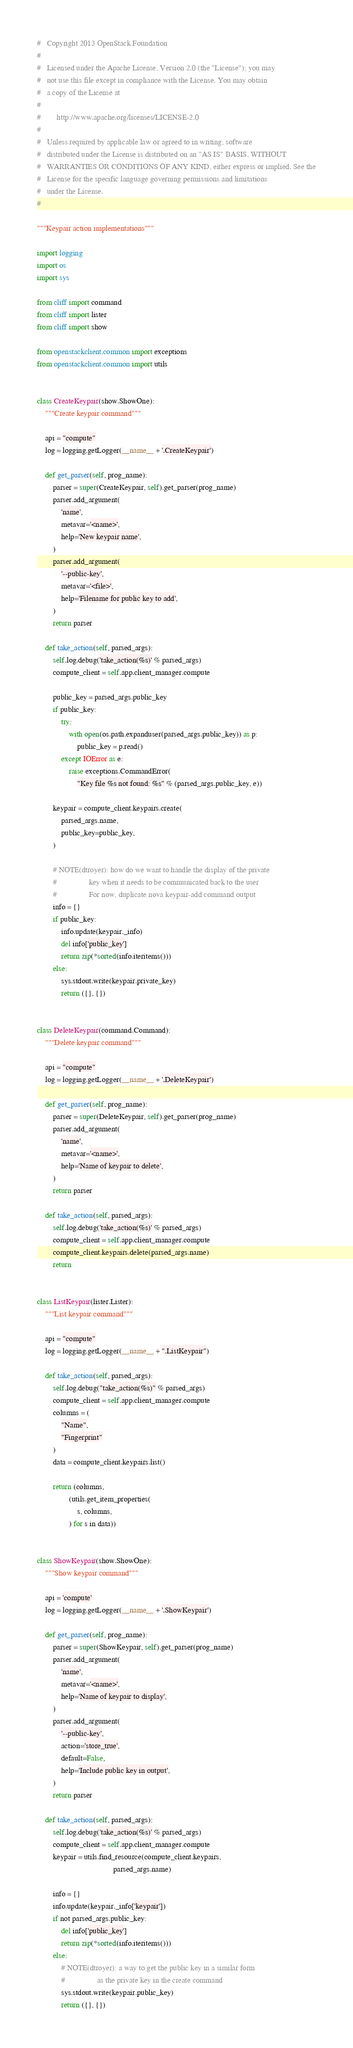Convert code to text. <code><loc_0><loc_0><loc_500><loc_500><_Python_>#   Copyright 2013 OpenStack Foundation
#
#   Licensed under the Apache License, Version 2.0 (the "License"); you may
#   not use this file except in compliance with the License. You may obtain
#   a copy of the License at
#
#        http://www.apache.org/licenses/LICENSE-2.0
#
#   Unless required by applicable law or agreed to in writing, software
#   distributed under the License is distributed on an "AS IS" BASIS, WITHOUT
#   WARRANTIES OR CONDITIONS OF ANY KIND, either express or implied. See the
#   License for the specific language governing permissions and limitations
#   under the License.
#

"""Keypair action implementations"""

import logging
import os
import sys

from cliff import command
from cliff import lister
from cliff import show

from openstackclient.common import exceptions
from openstackclient.common import utils


class CreateKeypair(show.ShowOne):
    """Create keypair command"""

    api = "compute"
    log = logging.getLogger(__name__ + '.CreateKeypair')

    def get_parser(self, prog_name):
        parser = super(CreateKeypair, self).get_parser(prog_name)
        parser.add_argument(
            'name',
            metavar='<name>',
            help='New keypair name',
        )
        parser.add_argument(
            '--public-key',
            metavar='<file>',
            help='Filename for public key to add',
        )
        return parser

    def take_action(self, parsed_args):
        self.log.debug('take_action(%s)' % parsed_args)
        compute_client = self.app.client_manager.compute

        public_key = parsed_args.public_key
        if public_key:
            try:
                with open(os.path.expanduser(parsed_args.public_key)) as p:
                    public_key = p.read()
            except IOError as e:
                raise exceptions.CommandError(
                    "Key file %s not found: %s" % (parsed_args.public_key, e))

        keypair = compute_client.keypairs.create(
            parsed_args.name,
            public_key=public_key,
        )

        # NOTE(dtroyer): how do we want to handle the display of the private
        #                key when it needs to be communicated back to the user
        #                For now, duplicate nova keypair-add command output
        info = {}
        if public_key:
            info.update(keypair._info)
            del info['public_key']
            return zip(*sorted(info.iteritems()))
        else:
            sys.stdout.write(keypair.private_key)
            return ({}, {})


class DeleteKeypair(command.Command):
    """Delete keypair command"""

    api = "compute"
    log = logging.getLogger(__name__ + '.DeleteKeypair')

    def get_parser(self, prog_name):
        parser = super(DeleteKeypair, self).get_parser(prog_name)
        parser.add_argument(
            'name',
            metavar='<name>',
            help='Name of keypair to delete',
        )
        return parser

    def take_action(self, parsed_args):
        self.log.debug('take_action(%s)' % parsed_args)
        compute_client = self.app.client_manager.compute
        compute_client.keypairs.delete(parsed_args.name)
        return


class ListKeypair(lister.Lister):
    """List keypair command"""

    api = "compute"
    log = logging.getLogger(__name__ + ".ListKeypair")

    def take_action(self, parsed_args):
        self.log.debug("take_action(%s)" % parsed_args)
        compute_client = self.app.client_manager.compute
        columns = (
            "Name",
            "Fingerprint"
        )
        data = compute_client.keypairs.list()

        return (columns,
                (utils.get_item_properties(
                    s, columns,
                ) for s in data))


class ShowKeypair(show.ShowOne):
    """Show keypair command"""

    api = 'compute'
    log = logging.getLogger(__name__ + '.ShowKeypair')

    def get_parser(self, prog_name):
        parser = super(ShowKeypair, self).get_parser(prog_name)
        parser.add_argument(
            'name',
            metavar='<name>',
            help='Name of keypair to display',
        )
        parser.add_argument(
            '--public-key',
            action='store_true',
            default=False,
            help='Include public key in output',
        )
        return parser

    def take_action(self, parsed_args):
        self.log.debug('take_action(%s)' % parsed_args)
        compute_client = self.app.client_manager.compute
        keypair = utils.find_resource(compute_client.keypairs,
                                      parsed_args.name)

        info = {}
        info.update(keypair._info['keypair'])
        if not parsed_args.public_key:
            del info['public_key']
            return zip(*sorted(info.iteritems()))
        else:
            # NOTE(dtroyer): a way to get the public key in a similar form
            #                as the private key in the create command
            sys.stdout.write(keypair.public_key)
            return ({}, {})
</code> 